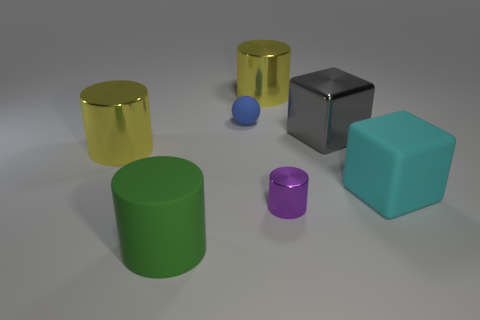How many matte things are the same color as the small shiny object?
Make the answer very short. 0. What material is the purple cylinder?
Your answer should be compact. Metal. Is the material of the yellow thing right of the big green matte object the same as the purple thing?
Provide a succinct answer. Yes. The big yellow object that is to the right of the blue rubber thing has what shape?
Your answer should be very brief. Cylinder. There is a cyan thing that is the same size as the gray block; what is its material?
Make the answer very short. Rubber. What number of objects are cylinders to the left of the purple shiny cylinder or matte things right of the small purple metallic cylinder?
Offer a very short reply. 4. What size is the cylinder that is the same material as the large cyan thing?
Make the answer very short. Large. What number of rubber things are large purple spheres or large gray cubes?
Provide a succinct answer. 0. The gray thing has what size?
Ensure brevity in your answer.  Large. Is the size of the green rubber thing the same as the cyan block?
Give a very brief answer. Yes. 